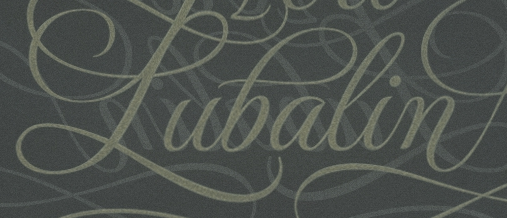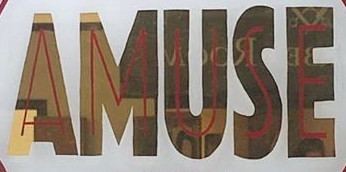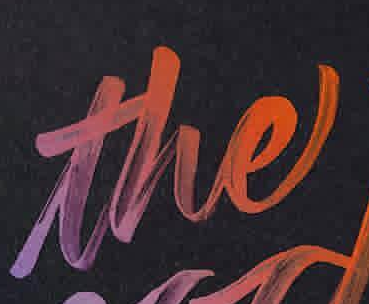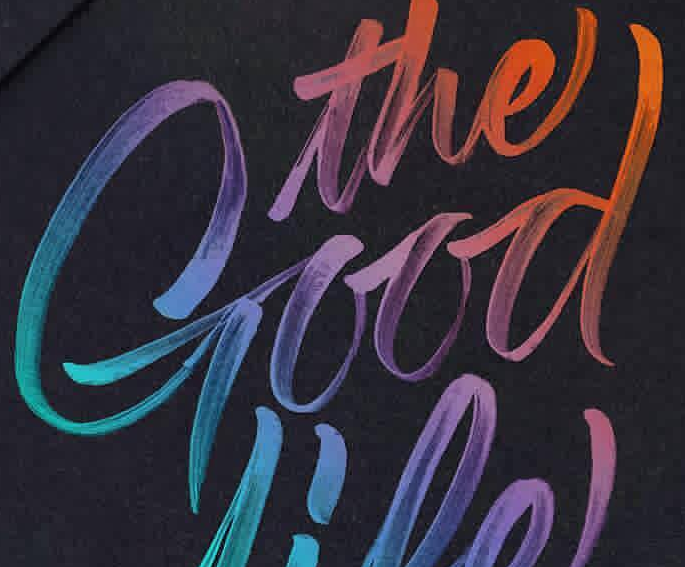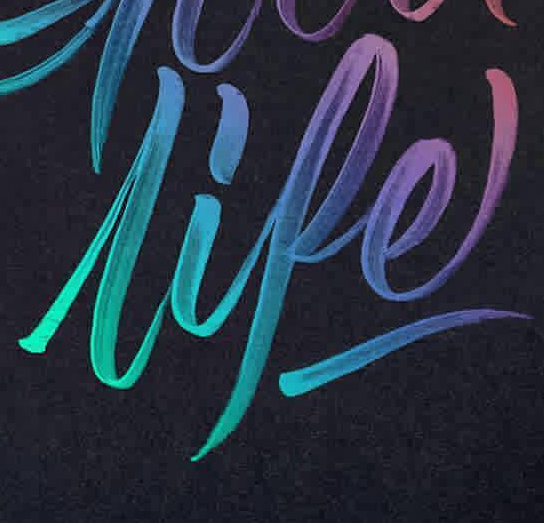What text is displayed in these images sequentially, separated by a semicolon? Pubalin; AMUSE; the; Good; lipe 